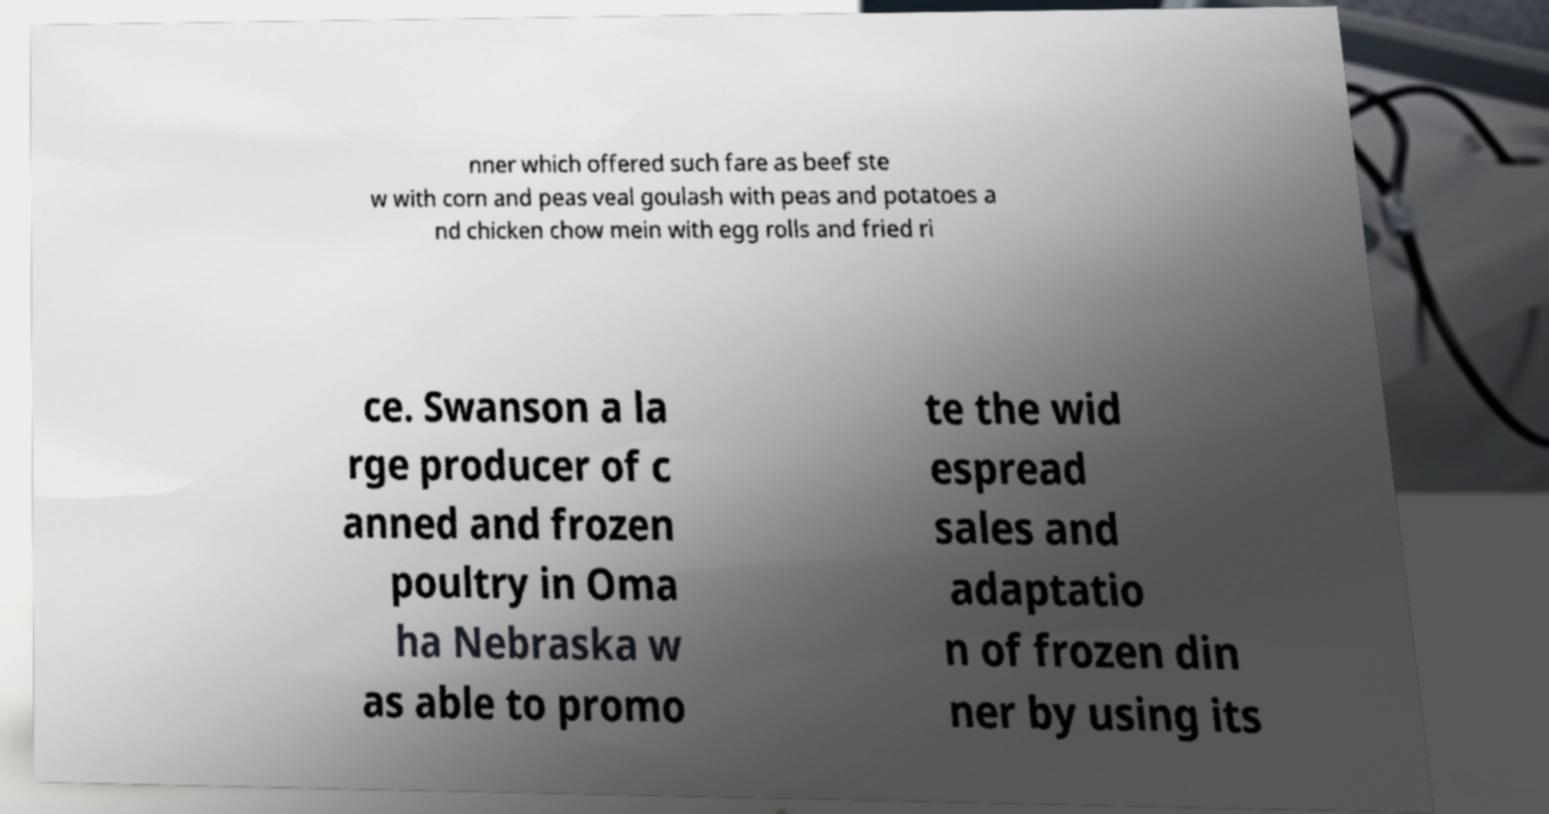Could you assist in decoding the text presented in this image and type it out clearly? nner which offered such fare as beef ste w with corn and peas veal goulash with peas and potatoes a nd chicken chow mein with egg rolls and fried ri ce. Swanson a la rge producer of c anned and frozen poultry in Oma ha Nebraska w as able to promo te the wid espread sales and adaptatio n of frozen din ner by using its 